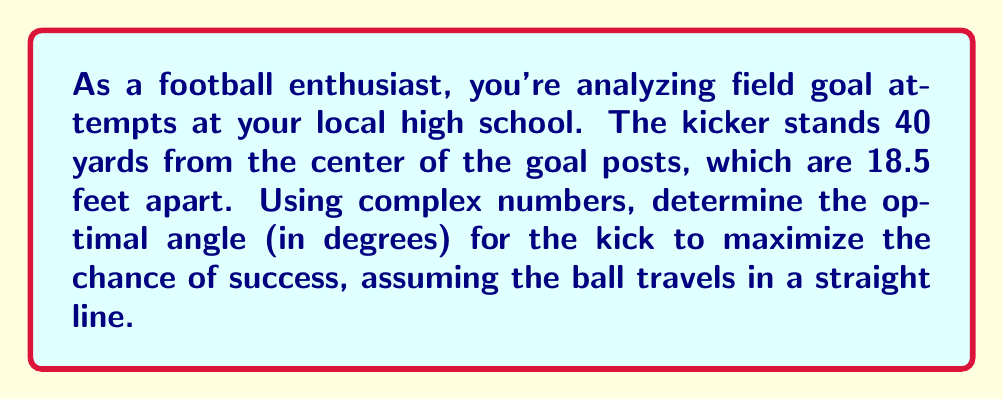Can you solve this math problem? Let's approach this step-by-step using complex numbers:

1) First, we'll set up a coordinate system. Let's place the kicker at the origin (0,0) and the center of the goal posts at (40,0) on the real axis.

2) We can represent the goal posts as complex numbers:
   Left post: $40 + 9.25i$ (since 18.5/2 = 9.25 feet)
   Right post: $40 - 9.25i$

3) The optimal angle will bisect these two points. To find this, we can add the two complex numbers and divide by 2:

   $$\frac{(40 + 9.25i) + (40 - 9.25i)}{2} = 40 + 0i = 40$$

4) This point (40,0) represents the center of the goal posts, which we already knew.

5) Now, we need to find the angle between the real axis and the line from (0,0) to (40,0i).

6) In complex number notation, this is equivalent to finding the argument of the complex number 40+0i.

7) The argument of a complex number $z = a + bi$ is given by $\arg(z) = \arctan(\frac{b}{a})$

8) In this case, $\arg(40+0i) = \arctan(\frac{0}{40}) = 0$

9) This means the optimal angle is 0 degrees from the real axis.

10) However, we typically measure field goal angles from the vertical. To convert, we subtract this angle from 90°:

    $$90° - 0° = 90°$$

Therefore, the optimal angle for the field goal kick is 90° from the vertical, or straight ahead.
Answer: 90° 